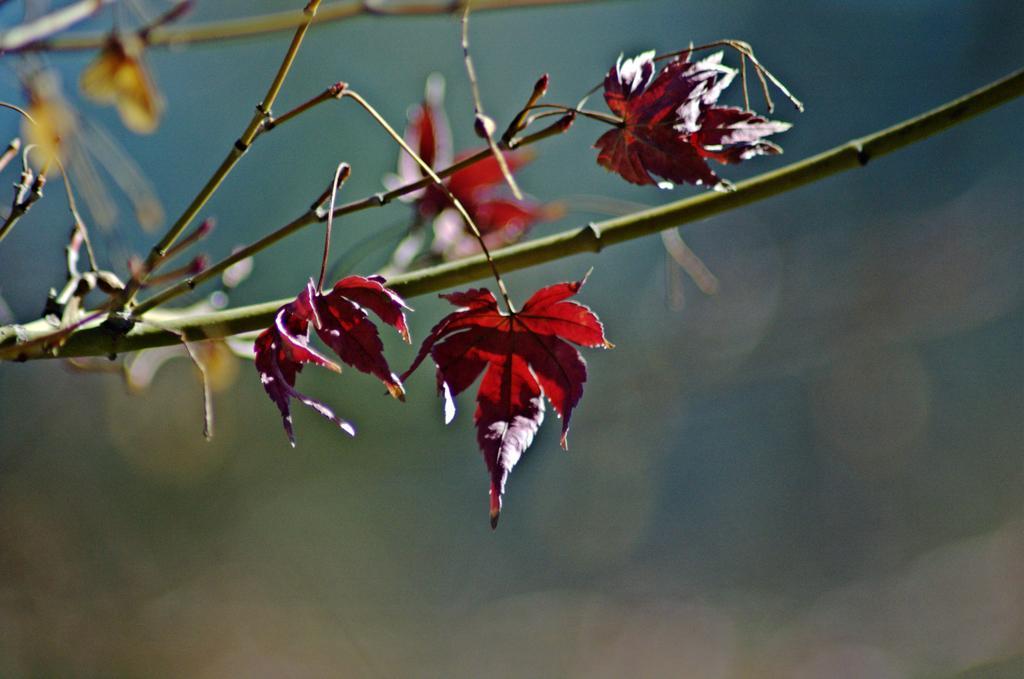Describe this image in one or two sentences. In this image we can see some leaves to the branches of a tree. 